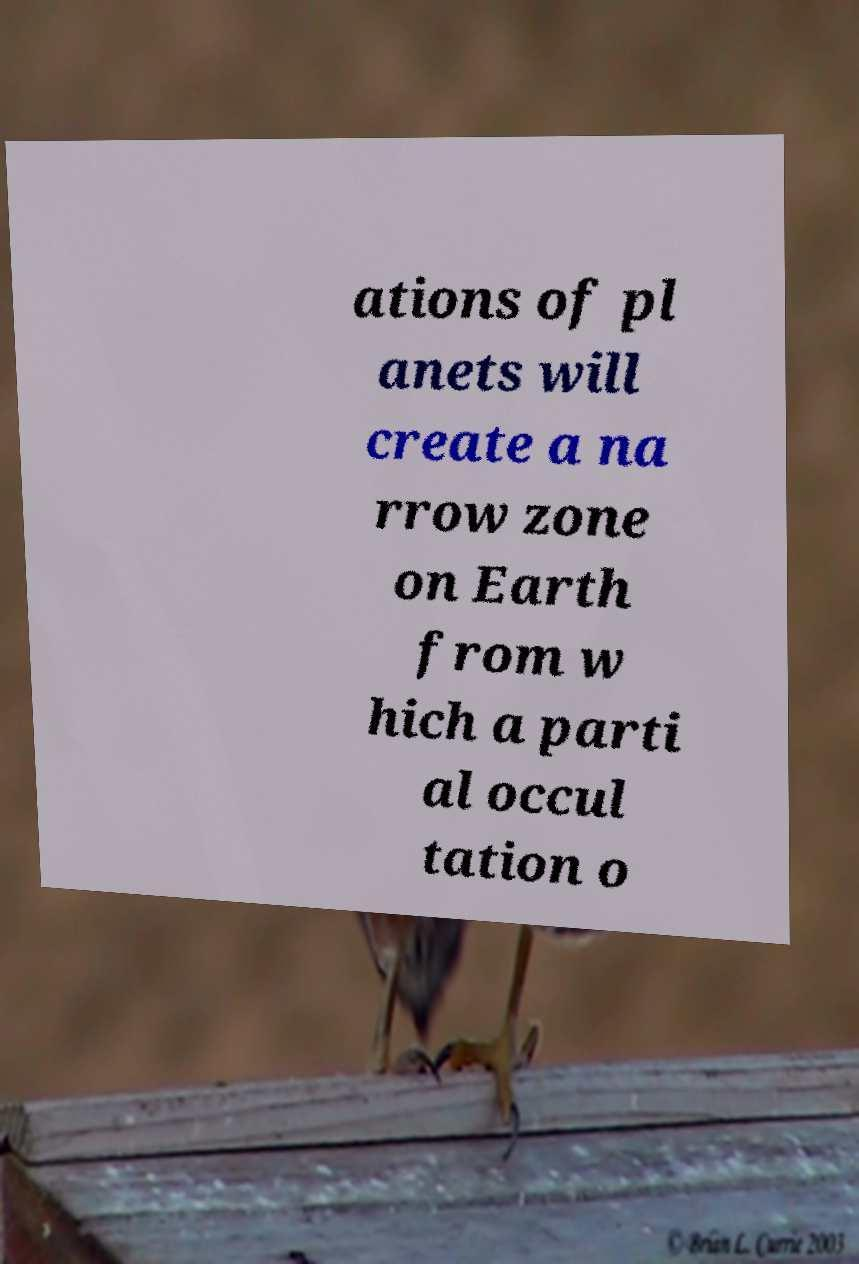Please read and relay the text visible in this image. What does it say? ations of pl anets will create a na rrow zone on Earth from w hich a parti al occul tation o 